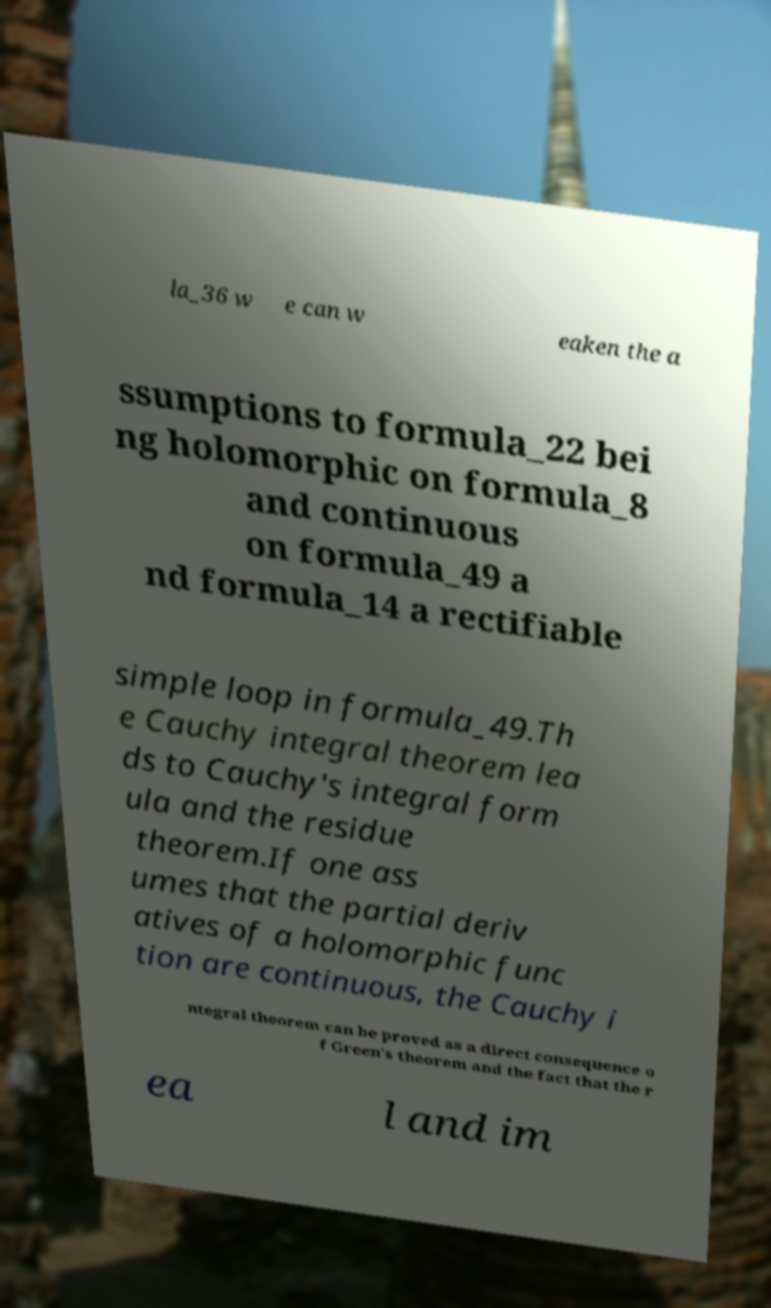Could you extract and type out the text from this image? la_36 w e can w eaken the a ssumptions to formula_22 bei ng holomorphic on formula_8 and continuous on formula_49 a nd formula_14 a rectifiable simple loop in formula_49.Th e Cauchy integral theorem lea ds to Cauchy's integral form ula and the residue theorem.If one ass umes that the partial deriv atives of a holomorphic func tion are continuous, the Cauchy i ntegral theorem can be proved as a direct consequence o f Green's theorem and the fact that the r ea l and im 